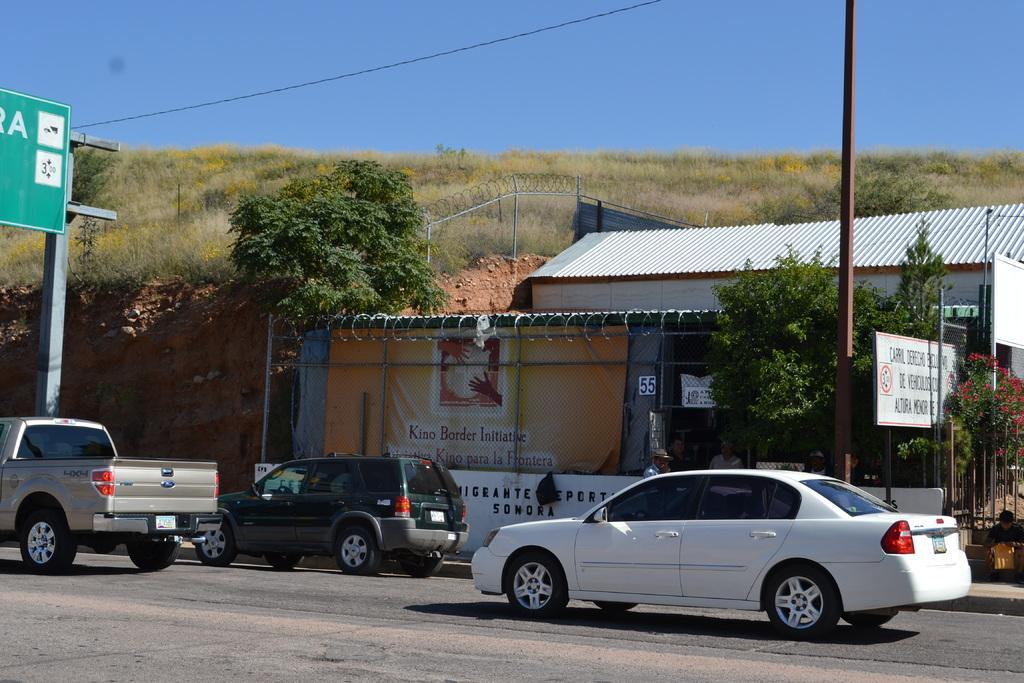Can you describe this image briefly? In this image there is a road, on that road there are three vehicles, in the background there are mountains and shops, trees and a blue sky. 